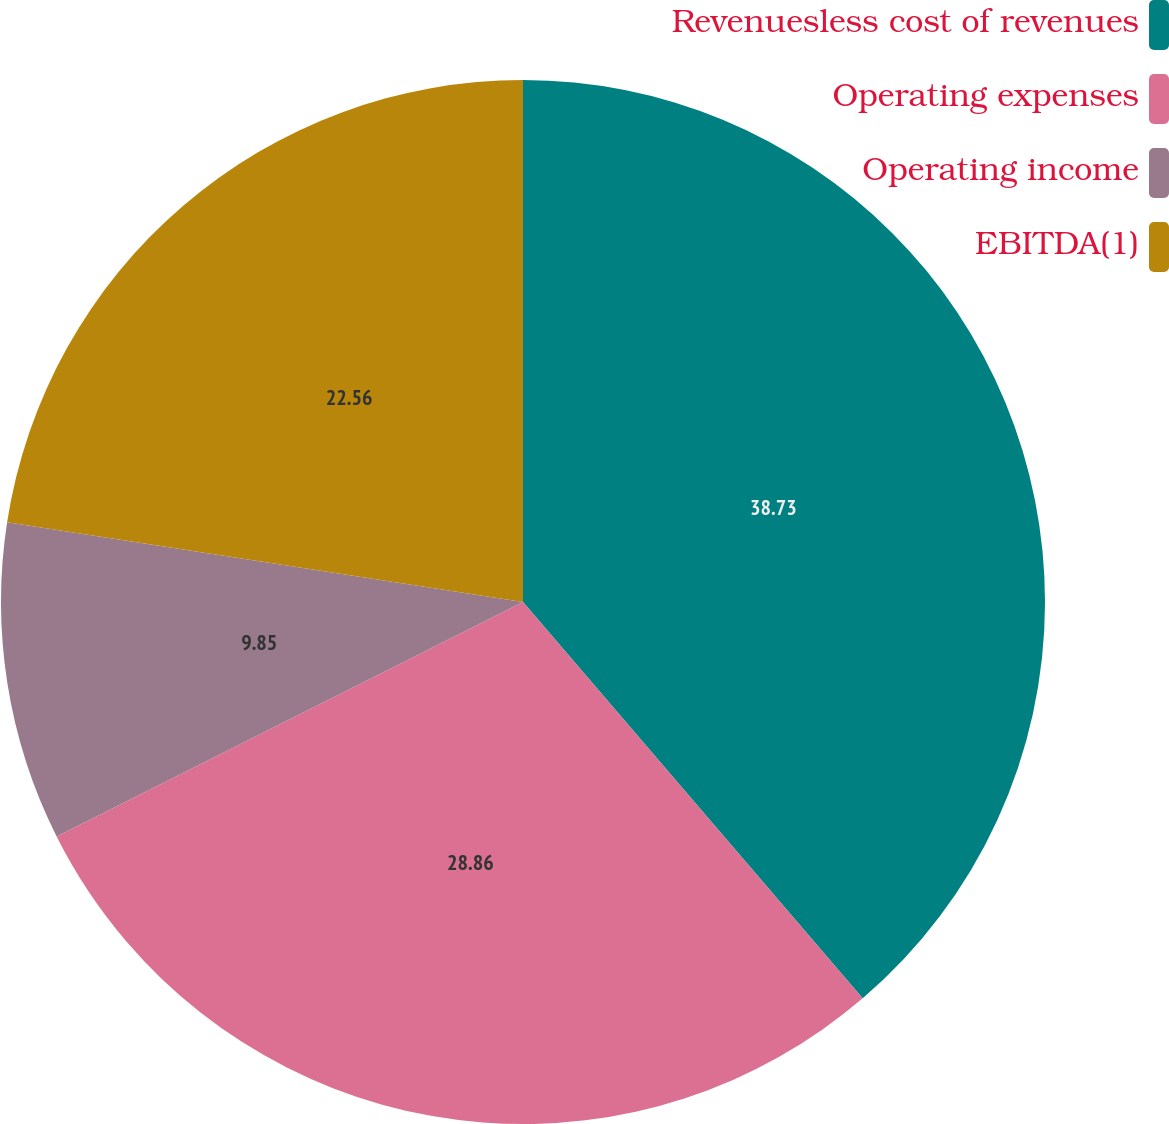<chart> <loc_0><loc_0><loc_500><loc_500><pie_chart><fcel>Revenuesless cost of revenues<fcel>Operating expenses<fcel>Operating income<fcel>EBITDA(1)<nl><fcel>38.72%<fcel>28.86%<fcel>9.85%<fcel>22.56%<nl></chart> 